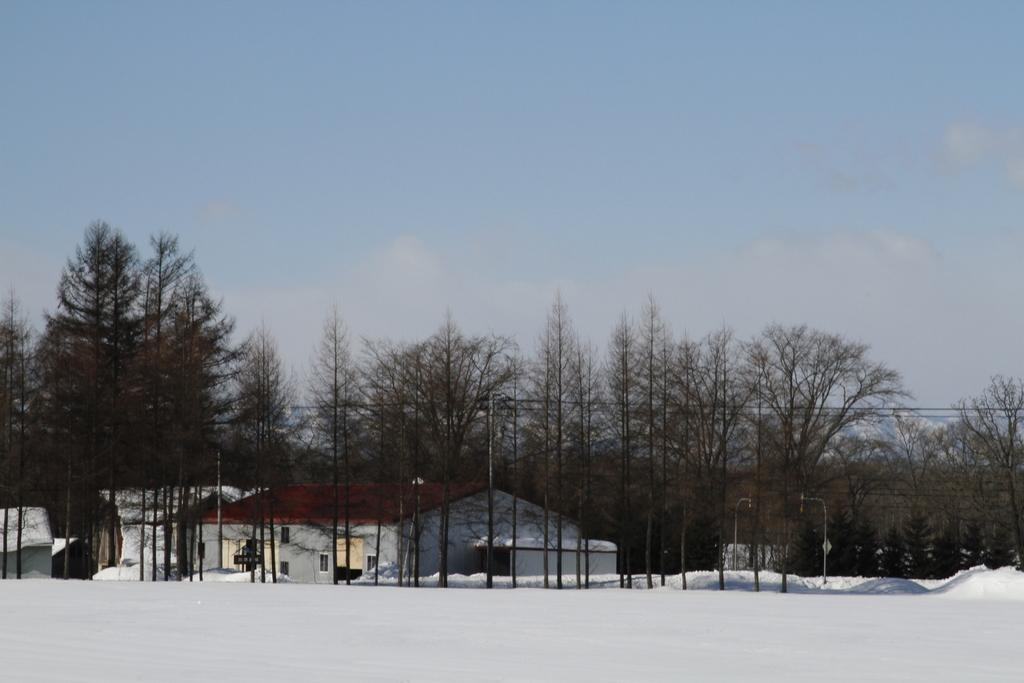What is the condition of the ground in the image? The ground in the image is covered in snow. What type of natural elements can be seen in the image? There are trees in the image. What man-made structures are present in the image? There are buildings in the image. What can be seen in the distance in the image? The sky is visible in the background of the image. What type of jail can be seen in the image? There is no jail present in the image. How many pages are visible in the image? There are no pages present in the image. 